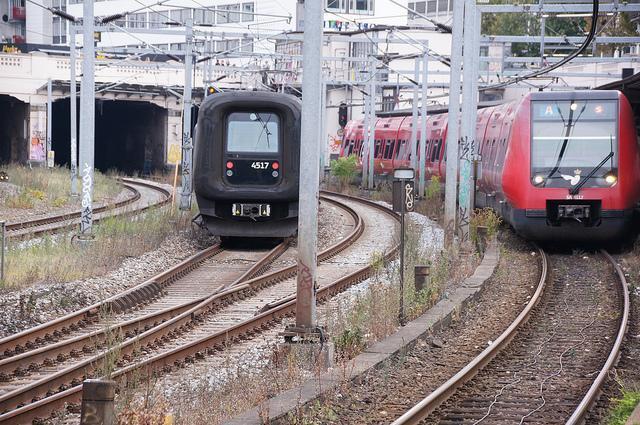The trains have what safety feature on the glass to help see visibly in stormy weather?
From the following set of four choices, select the accurate answer to respond to the question.
Options: Turning signals, windshield wipers, high beams, fog heater. Windshield wipers. 